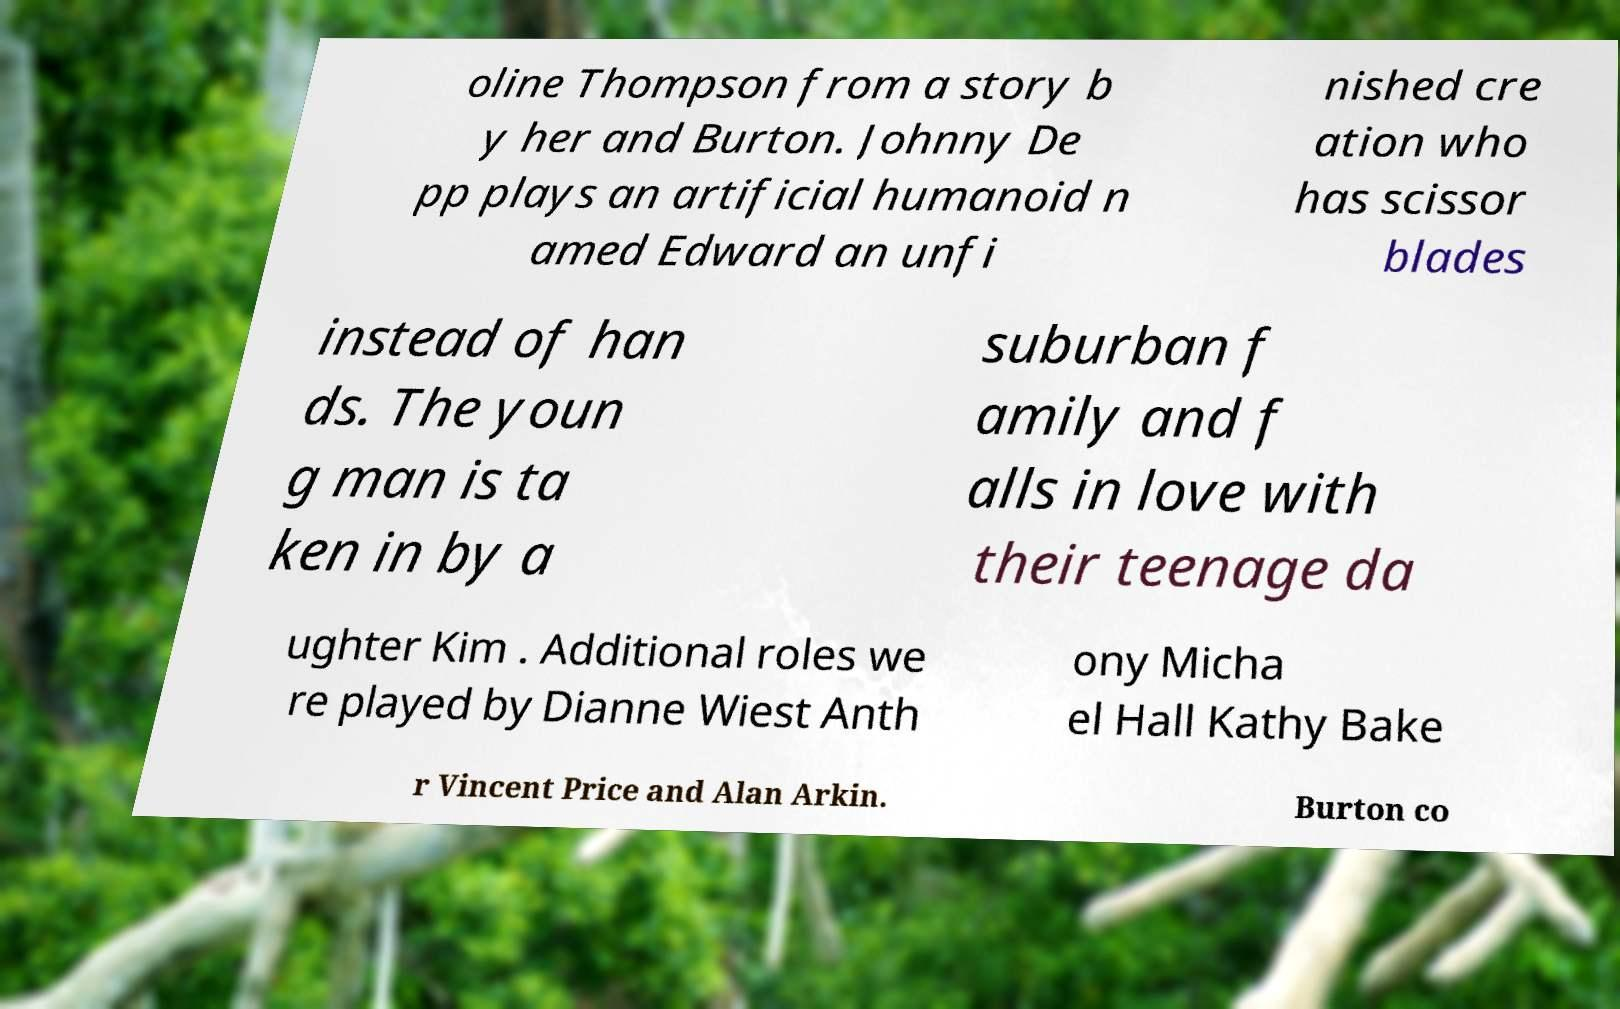Can you read and provide the text displayed in the image?This photo seems to have some interesting text. Can you extract and type it out for me? oline Thompson from a story b y her and Burton. Johnny De pp plays an artificial humanoid n amed Edward an unfi nished cre ation who has scissor blades instead of han ds. The youn g man is ta ken in by a suburban f amily and f alls in love with their teenage da ughter Kim . Additional roles we re played by Dianne Wiest Anth ony Micha el Hall Kathy Bake r Vincent Price and Alan Arkin. Burton co 